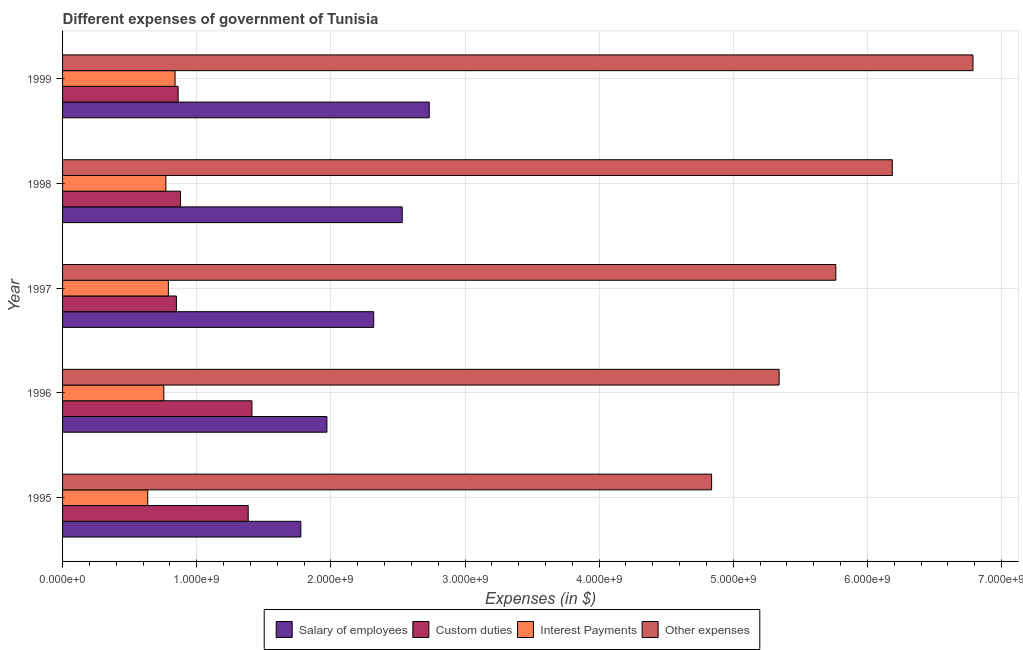How many different coloured bars are there?
Offer a terse response. 4. How many groups of bars are there?
Ensure brevity in your answer.  5. How many bars are there on the 4th tick from the top?
Your answer should be compact. 4. What is the label of the 2nd group of bars from the top?
Your answer should be very brief. 1998. In how many cases, is the number of bars for a given year not equal to the number of legend labels?
Offer a very short reply. 0. What is the amount spent on interest payments in 1996?
Give a very brief answer. 7.55e+08. Across all years, what is the maximum amount spent on other expenses?
Your answer should be compact. 6.79e+09. Across all years, what is the minimum amount spent on other expenses?
Provide a short and direct response. 4.84e+09. In which year was the amount spent on custom duties minimum?
Keep it short and to the point. 1997. What is the total amount spent on salary of employees in the graph?
Your response must be concise. 1.13e+1. What is the difference between the amount spent on salary of employees in 1998 and that in 1999?
Offer a very short reply. -2.01e+08. What is the difference between the amount spent on interest payments in 1997 and the amount spent on other expenses in 1996?
Offer a terse response. -4.55e+09. What is the average amount spent on interest payments per year?
Make the answer very short. 7.57e+08. In the year 1996, what is the difference between the amount spent on interest payments and amount spent on other expenses?
Your answer should be compact. -4.59e+09. What is the ratio of the amount spent on custom duties in 1998 to that in 1999?
Your answer should be compact. 1.02. Is the difference between the amount spent on custom duties in 1998 and 1999 greater than the difference between the amount spent on salary of employees in 1998 and 1999?
Your response must be concise. Yes. What is the difference between the highest and the second highest amount spent on other expenses?
Provide a succinct answer. 6.01e+08. What is the difference between the highest and the lowest amount spent on interest payments?
Give a very brief answer. 2.03e+08. In how many years, is the amount spent on other expenses greater than the average amount spent on other expenses taken over all years?
Make the answer very short. 2. Is the sum of the amount spent on other expenses in 1995 and 1997 greater than the maximum amount spent on salary of employees across all years?
Your answer should be very brief. Yes. Is it the case that in every year, the sum of the amount spent on other expenses and amount spent on custom duties is greater than the sum of amount spent on interest payments and amount spent on salary of employees?
Ensure brevity in your answer.  Yes. What does the 3rd bar from the top in 1999 represents?
Your answer should be very brief. Custom duties. What does the 2nd bar from the bottom in 1999 represents?
Your answer should be very brief. Custom duties. How many years are there in the graph?
Offer a very short reply. 5. What is the difference between two consecutive major ticks on the X-axis?
Your answer should be compact. 1.00e+09. Are the values on the major ticks of X-axis written in scientific E-notation?
Offer a terse response. Yes. Does the graph contain grids?
Ensure brevity in your answer.  Yes. How are the legend labels stacked?
Offer a very short reply. Horizontal. What is the title of the graph?
Keep it short and to the point. Different expenses of government of Tunisia. What is the label or title of the X-axis?
Your answer should be very brief. Expenses (in $). What is the Expenses (in $) of Salary of employees in 1995?
Your answer should be compact. 1.78e+09. What is the Expenses (in $) of Custom duties in 1995?
Keep it short and to the point. 1.38e+09. What is the Expenses (in $) in Interest Payments in 1995?
Your answer should be very brief. 6.35e+08. What is the Expenses (in $) in Other expenses in 1995?
Your answer should be very brief. 4.84e+09. What is the Expenses (in $) of Salary of employees in 1996?
Provide a succinct answer. 1.97e+09. What is the Expenses (in $) in Custom duties in 1996?
Make the answer very short. 1.41e+09. What is the Expenses (in $) of Interest Payments in 1996?
Offer a terse response. 7.55e+08. What is the Expenses (in $) in Other expenses in 1996?
Make the answer very short. 5.34e+09. What is the Expenses (in $) of Salary of employees in 1997?
Provide a succinct answer. 2.32e+09. What is the Expenses (in $) in Custom duties in 1997?
Ensure brevity in your answer.  8.49e+08. What is the Expenses (in $) of Interest Payments in 1997?
Keep it short and to the point. 7.89e+08. What is the Expenses (in $) in Other expenses in 1997?
Provide a short and direct response. 5.76e+09. What is the Expenses (in $) in Salary of employees in 1998?
Make the answer very short. 2.53e+09. What is the Expenses (in $) of Custom duties in 1998?
Your answer should be very brief. 8.79e+08. What is the Expenses (in $) in Interest Payments in 1998?
Offer a very short reply. 7.70e+08. What is the Expenses (in $) of Other expenses in 1998?
Give a very brief answer. 6.19e+09. What is the Expenses (in $) of Salary of employees in 1999?
Your answer should be very brief. 2.73e+09. What is the Expenses (in $) in Custom duties in 1999?
Your response must be concise. 8.62e+08. What is the Expenses (in $) in Interest Payments in 1999?
Give a very brief answer. 8.38e+08. What is the Expenses (in $) in Other expenses in 1999?
Your answer should be very brief. 6.79e+09. Across all years, what is the maximum Expenses (in $) of Salary of employees?
Your answer should be compact. 2.73e+09. Across all years, what is the maximum Expenses (in $) in Custom duties?
Offer a terse response. 1.41e+09. Across all years, what is the maximum Expenses (in $) of Interest Payments?
Provide a succinct answer. 8.38e+08. Across all years, what is the maximum Expenses (in $) in Other expenses?
Give a very brief answer. 6.79e+09. Across all years, what is the minimum Expenses (in $) of Salary of employees?
Ensure brevity in your answer.  1.78e+09. Across all years, what is the minimum Expenses (in $) of Custom duties?
Your answer should be compact. 8.49e+08. Across all years, what is the minimum Expenses (in $) of Interest Payments?
Your response must be concise. 6.35e+08. Across all years, what is the minimum Expenses (in $) of Other expenses?
Your answer should be compact. 4.84e+09. What is the total Expenses (in $) in Salary of employees in the graph?
Your answer should be very brief. 1.13e+1. What is the total Expenses (in $) in Custom duties in the graph?
Offer a very short reply. 5.39e+09. What is the total Expenses (in $) of Interest Payments in the graph?
Make the answer very short. 3.79e+09. What is the total Expenses (in $) of Other expenses in the graph?
Give a very brief answer. 2.89e+1. What is the difference between the Expenses (in $) in Salary of employees in 1995 and that in 1996?
Your answer should be very brief. -1.94e+08. What is the difference between the Expenses (in $) in Custom duties in 1995 and that in 1996?
Keep it short and to the point. -2.77e+07. What is the difference between the Expenses (in $) of Interest Payments in 1995 and that in 1996?
Offer a very short reply. -1.20e+08. What is the difference between the Expenses (in $) of Other expenses in 1995 and that in 1996?
Offer a very short reply. -5.03e+08. What is the difference between the Expenses (in $) of Salary of employees in 1995 and that in 1997?
Your answer should be very brief. -5.43e+08. What is the difference between the Expenses (in $) in Custom duties in 1995 and that in 1997?
Ensure brevity in your answer.  5.35e+08. What is the difference between the Expenses (in $) in Interest Payments in 1995 and that in 1997?
Your answer should be compact. -1.54e+08. What is the difference between the Expenses (in $) of Other expenses in 1995 and that in 1997?
Your answer should be compact. -9.26e+08. What is the difference between the Expenses (in $) of Salary of employees in 1995 and that in 1998?
Keep it short and to the point. -7.56e+08. What is the difference between the Expenses (in $) in Custom duties in 1995 and that in 1998?
Offer a very short reply. 5.05e+08. What is the difference between the Expenses (in $) of Interest Payments in 1995 and that in 1998?
Your response must be concise. -1.35e+08. What is the difference between the Expenses (in $) of Other expenses in 1995 and that in 1998?
Offer a very short reply. -1.35e+09. What is the difference between the Expenses (in $) in Salary of employees in 1995 and that in 1999?
Give a very brief answer. -9.57e+08. What is the difference between the Expenses (in $) of Custom duties in 1995 and that in 1999?
Offer a terse response. 5.22e+08. What is the difference between the Expenses (in $) of Interest Payments in 1995 and that in 1999?
Offer a terse response. -2.03e+08. What is the difference between the Expenses (in $) in Other expenses in 1995 and that in 1999?
Provide a short and direct response. -1.95e+09. What is the difference between the Expenses (in $) of Salary of employees in 1996 and that in 1997?
Offer a terse response. -3.49e+08. What is the difference between the Expenses (in $) of Custom duties in 1996 and that in 1997?
Ensure brevity in your answer.  5.63e+08. What is the difference between the Expenses (in $) of Interest Payments in 1996 and that in 1997?
Offer a very short reply. -3.40e+07. What is the difference between the Expenses (in $) of Other expenses in 1996 and that in 1997?
Your response must be concise. -4.22e+08. What is the difference between the Expenses (in $) in Salary of employees in 1996 and that in 1998?
Offer a very short reply. -5.62e+08. What is the difference between the Expenses (in $) of Custom duties in 1996 and that in 1998?
Provide a short and direct response. 5.32e+08. What is the difference between the Expenses (in $) in Interest Payments in 1996 and that in 1998?
Ensure brevity in your answer.  -1.53e+07. What is the difference between the Expenses (in $) of Other expenses in 1996 and that in 1998?
Your response must be concise. -8.44e+08. What is the difference between the Expenses (in $) of Salary of employees in 1996 and that in 1999?
Offer a very short reply. -7.63e+08. What is the difference between the Expenses (in $) of Custom duties in 1996 and that in 1999?
Your response must be concise. 5.50e+08. What is the difference between the Expenses (in $) of Interest Payments in 1996 and that in 1999?
Your answer should be compact. -8.38e+07. What is the difference between the Expenses (in $) of Other expenses in 1996 and that in 1999?
Give a very brief answer. -1.44e+09. What is the difference between the Expenses (in $) in Salary of employees in 1997 and that in 1998?
Provide a succinct answer. -2.13e+08. What is the difference between the Expenses (in $) of Custom duties in 1997 and that in 1998?
Your answer should be very brief. -3.08e+07. What is the difference between the Expenses (in $) in Interest Payments in 1997 and that in 1998?
Provide a succinct answer. 1.87e+07. What is the difference between the Expenses (in $) in Other expenses in 1997 and that in 1998?
Provide a short and direct response. -4.21e+08. What is the difference between the Expenses (in $) of Salary of employees in 1997 and that in 1999?
Make the answer very short. -4.14e+08. What is the difference between the Expenses (in $) of Custom duties in 1997 and that in 1999?
Your answer should be compact. -1.29e+07. What is the difference between the Expenses (in $) in Interest Payments in 1997 and that in 1999?
Provide a succinct answer. -4.98e+07. What is the difference between the Expenses (in $) in Other expenses in 1997 and that in 1999?
Provide a short and direct response. -1.02e+09. What is the difference between the Expenses (in $) of Salary of employees in 1998 and that in 1999?
Make the answer very short. -2.01e+08. What is the difference between the Expenses (in $) of Custom duties in 1998 and that in 1999?
Give a very brief answer. 1.79e+07. What is the difference between the Expenses (in $) of Interest Payments in 1998 and that in 1999?
Your response must be concise. -6.85e+07. What is the difference between the Expenses (in $) of Other expenses in 1998 and that in 1999?
Give a very brief answer. -6.01e+08. What is the difference between the Expenses (in $) in Salary of employees in 1995 and the Expenses (in $) in Custom duties in 1996?
Your answer should be compact. 3.64e+08. What is the difference between the Expenses (in $) of Salary of employees in 1995 and the Expenses (in $) of Interest Payments in 1996?
Offer a terse response. 1.02e+09. What is the difference between the Expenses (in $) of Salary of employees in 1995 and the Expenses (in $) of Other expenses in 1996?
Offer a terse response. -3.57e+09. What is the difference between the Expenses (in $) in Custom duties in 1995 and the Expenses (in $) in Interest Payments in 1996?
Offer a very short reply. 6.29e+08. What is the difference between the Expenses (in $) in Custom duties in 1995 and the Expenses (in $) in Other expenses in 1996?
Offer a terse response. -3.96e+09. What is the difference between the Expenses (in $) of Interest Payments in 1995 and the Expenses (in $) of Other expenses in 1996?
Offer a very short reply. -4.71e+09. What is the difference between the Expenses (in $) in Salary of employees in 1995 and the Expenses (in $) in Custom duties in 1997?
Give a very brief answer. 9.28e+08. What is the difference between the Expenses (in $) in Salary of employees in 1995 and the Expenses (in $) in Interest Payments in 1997?
Offer a terse response. 9.88e+08. What is the difference between the Expenses (in $) of Salary of employees in 1995 and the Expenses (in $) of Other expenses in 1997?
Make the answer very short. -3.99e+09. What is the difference between the Expenses (in $) in Custom duties in 1995 and the Expenses (in $) in Interest Payments in 1997?
Provide a short and direct response. 5.95e+08. What is the difference between the Expenses (in $) of Custom duties in 1995 and the Expenses (in $) of Other expenses in 1997?
Provide a succinct answer. -4.38e+09. What is the difference between the Expenses (in $) of Interest Payments in 1995 and the Expenses (in $) of Other expenses in 1997?
Offer a very short reply. -5.13e+09. What is the difference between the Expenses (in $) in Salary of employees in 1995 and the Expenses (in $) in Custom duties in 1998?
Offer a terse response. 8.97e+08. What is the difference between the Expenses (in $) in Salary of employees in 1995 and the Expenses (in $) in Interest Payments in 1998?
Your answer should be compact. 1.01e+09. What is the difference between the Expenses (in $) in Salary of employees in 1995 and the Expenses (in $) in Other expenses in 1998?
Provide a succinct answer. -4.41e+09. What is the difference between the Expenses (in $) in Custom duties in 1995 and the Expenses (in $) in Interest Payments in 1998?
Provide a succinct answer. 6.14e+08. What is the difference between the Expenses (in $) in Custom duties in 1995 and the Expenses (in $) in Other expenses in 1998?
Your response must be concise. -4.80e+09. What is the difference between the Expenses (in $) in Interest Payments in 1995 and the Expenses (in $) in Other expenses in 1998?
Keep it short and to the point. -5.55e+09. What is the difference between the Expenses (in $) in Salary of employees in 1995 and the Expenses (in $) in Custom duties in 1999?
Offer a very short reply. 9.15e+08. What is the difference between the Expenses (in $) in Salary of employees in 1995 and the Expenses (in $) in Interest Payments in 1999?
Your answer should be compact. 9.38e+08. What is the difference between the Expenses (in $) of Salary of employees in 1995 and the Expenses (in $) of Other expenses in 1999?
Offer a very short reply. -5.01e+09. What is the difference between the Expenses (in $) of Custom duties in 1995 and the Expenses (in $) of Interest Payments in 1999?
Give a very brief answer. 5.46e+08. What is the difference between the Expenses (in $) of Custom duties in 1995 and the Expenses (in $) of Other expenses in 1999?
Your answer should be very brief. -5.40e+09. What is the difference between the Expenses (in $) in Interest Payments in 1995 and the Expenses (in $) in Other expenses in 1999?
Your response must be concise. -6.15e+09. What is the difference between the Expenses (in $) in Salary of employees in 1996 and the Expenses (in $) in Custom duties in 1997?
Keep it short and to the point. 1.12e+09. What is the difference between the Expenses (in $) of Salary of employees in 1996 and the Expenses (in $) of Interest Payments in 1997?
Offer a very short reply. 1.18e+09. What is the difference between the Expenses (in $) in Salary of employees in 1996 and the Expenses (in $) in Other expenses in 1997?
Keep it short and to the point. -3.79e+09. What is the difference between the Expenses (in $) of Custom duties in 1996 and the Expenses (in $) of Interest Payments in 1997?
Ensure brevity in your answer.  6.23e+08. What is the difference between the Expenses (in $) of Custom duties in 1996 and the Expenses (in $) of Other expenses in 1997?
Give a very brief answer. -4.35e+09. What is the difference between the Expenses (in $) of Interest Payments in 1996 and the Expenses (in $) of Other expenses in 1997?
Ensure brevity in your answer.  -5.01e+09. What is the difference between the Expenses (in $) in Salary of employees in 1996 and the Expenses (in $) in Custom duties in 1998?
Your answer should be compact. 1.09e+09. What is the difference between the Expenses (in $) of Salary of employees in 1996 and the Expenses (in $) of Interest Payments in 1998?
Your response must be concise. 1.20e+09. What is the difference between the Expenses (in $) of Salary of employees in 1996 and the Expenses (in $) of Other expenses in 1998?
Provide a short and direct response. -4.21e+09. What is the difference between the Expenses (in $) of Custom duties in 1996 and the Expenses (in $) of Interest Payments in 1998?
Offer a very short reply. 6.42e+08. What is the difference between the Expenses (in $) in Custom duties in 1996 and the Expenses (in $) in Other expenses in 1998?
Ensure brevity in your answer.  -4.77e+09. What is the difference between the Expenses (in $) of Interest Payments in 1996 and the Expenses (in $) of Other expenses in 1998?
Your answer should be very brief. -5.43e+09. What is the difference between the Expenses (in $) in Salary of employees in 1996 and the Expenses (in $) in Custom duties in 1999?
Make the answer very short. 1.11e+09. What is the difference between the Expenses (in $) in Salary of employees in 1996 and the Expenses (in $) in Interest Payments in 1999?
Your response must be concise. 1.13e+09. What is the difference between the Expenses (in $) in Salary of employees in 1996 and the Expenses (in $) in Other expenses in 1999?
Your answer should be compact. -4.82e+09. What is the difference between the Expenses (in $) of Custom duties in 1996 and the Expenses (in $) of Interest Payments in 1999?
Your response must be concise. 5.73e+08. What is the difference between the Expenses (in $) of Custom duties in 1996 and the Expenses (in $) of Other expenses in 1999?
Ensure brevity in your answer.  -5.38e+09. What is the difference between the Expenses (in $) of Interest Payments in 1996 and the Expenses (in $) of Other expenses in 1999?
Your response must be concise. -6.03e+09. What is the difference between the Expenses (in $) of Salary of employees in 1997 and the Expenses (in $) of Custom duties in 1998?
Offer a very short reply. 1.44e+09. What is the difference between the Expenses (in $) in Salary of employees in 1997 and the Expenses (in $) in Interest Payments in 1998?
Keep it short and to the point. 1.55e+09. What is the difference between the Expenses (in $) of Salary of employees in 1997 and the Expenses (in $) of Other expenses in 1998?
Your answer should be compact. -3.87e+09. What is the difference between the Expenses (in $) in Custom duties in 1997 and the Expenses (in $) in Interest Payments in 1998?
Provide a short and direct response. 7.86e+07. What is the difference between the Expenses (in $) in Custom duties in 1997 and the Expenses (in $) in Other expenses in 1998?
Offer a terse response. -5.34e+09. What is the difference between the Expenses (in $) of Interest Payments in 1997 and the Expenses (in $) of Other expenses in 1998?
Your answer should be compact. -5.40e+09. What is the difference between the Expenses (in $) in Salary of employees in 1997 and the Expenses (in $) in Custom duties in 1999?
Keep it short and to the point. 1.46e+09. What is the difference between the Expenses (in $) of Salary of employees in 1997 and the Expenses (in $) of Interest Payments in 1999?
Ensure brevity in your answer.  1.48e+09. What is the difference between the Expenses (in $) in Salary of employees in 1997 and the Expenses (in $) in Other expenses in 1999?
Your response must be concise. -4.47e+09. What is the difference between the Expenses (in $) in Custom duties in 1997 and the Expenses (in $) in Interest Payments in 1999?
Offer a very short reply. 1.01e+07. What is the difference between the Expenses (in $) in Custom duties in 1997 and the Expenses (in $) in Other expenses in 1999?
Offer a very short reply. -5.94e+09. What is the difference between the Expenses (in $) in Interest Payments in 1997 and the Expenses (in $) in Other expenses in 1999?
Keep it short and to the point. -6.00e+09. What is the difference between the Expenses (in $) of Salary of employees in 1998 and the Expenses (in $) of Custom duties in 1999?
Offer a very short reply. 1.67e+09. What is the difference between the Expenses (in $) in Salary of employees in 1998 and the Expenses (in $) in Interest Payments in 1999?
Your response must be concise. 1.69e+09. What is the difference between the Expenses (in $) in Salary of employees in 1998 and the Expenses (in $) in Other expenses in 1999?
Offer a terse response. -4.25e+09. What is the difference between the Expenses (in $) in Custom duties in 1998 and the Expenses (in $) in Interest Payments in 1999?
Offer a terse response. 4.09e+07. What is the difference between the Expenses (in $) of Custom duties in 1998 and the Expenses (in $) of Other expenses in 1999?
Your answer should be compact. -5.91e+09. What is the difference between the Expenses (in $) in Interest Payments in 1998 and the Expenses (in $) in Other expenses in 1999?
Provide a short and direct response. -6.02e+09. What is the average Expenses (in $) of Salary of employees per year?
Offer a terse response. 2.27e+09. What is the average Expenses (in $) of Custom duties per year?
Provide a succinct answer. 1.08e+09. What is the average Expenses (in $) of Interest Payments per year?
Offer a terse response. 7.57e+08. What is the average Expenses (in $) in Other expenses per year?
Your answer should be compact. 5.78e+09. In the year 1995, what is the difference between the Expenses (in $) of Salary of employees and Expenses (in $) of Custom duties?
Make the answer very short. 3.92e+08. In the year 1995, what is the difference between the Expenses (in $) of Salary of employees and Expenses (in $) of Interest Payments?
Offer a terse response. 1.14e+09. In the year 1995, what is the difference between the Expenses (in $) of Salary of employees and Expenses (in $) of Other expenses?
Ensure brevity in your answer.  -3.06e+09. In the year 1995, what is the difference between the Expenses (in $) of Custom duties and Expenses (in $) of Interest Payments?
Your response must be concise. 7.49e+08. In the year 1995, what is the difference between the Expenses (in $) of Custom duties and Expenses (in $) of Other expenses?
Your response must be concise. -3.45e+09. In the year 1995, what is the difference between the Expenses (in $) of Interest Payments and Expenses (in $) of Other expenses?
Your answer should be compact. -4.20e+09. In the year 1996, what is the difference between the Expenses (in $) in Salary of employees and Expenses (in $) in Custom duties?
Offer a terse response. 5.59e+08. In the year 1996, what is the difference between the Expenses (in $) of Salary of employees and Expenses (in $) of Interest Payments?
Offer a terse response. 1.22e+09. In the year 1996, what is the difference between the Expenses (in $) of Salary of employees and Expenses (in $) of Other expenses?
Provide a succinct answer. -3.37e+09. In the year 1996, what is the difference between the Expenses (in $) of Custom duties and Expenses (in $) of Interest Payments?
Keep it short and to the point. 6.57e+08. In the year 1996, what is the difference between the Expenses (in $) of Custom duties and Expenses (in $) of Other expenses?
Ensure brevity in your answer.  -3.93e+09. In the year 1996, what is the difference between the Expenses (in $) of Interest Payments and Expenses (in $) of Other expenses?
Give a very brief answer. -4.59e+09. In the year 1997, what is the difference between the Expenses (in $) in Salary of employees and Expenses (in $) in Custom duties?
Your answer should be very brief. 1.47e+09. In the year 1997, what is the difference between the Expenses (in $) in Salary of employees and Expenses (in $) in Interest Payments?
Provide a short and direct response. 1.53e+09. In the year 1997, what is the difference between the Expenses (in $) of Salary of employees and Expenses (in $) of Other expenses?
Give a very brief answer. -3.44e+09. In the year 1997, what is the difference between the Expenses (in $) of Custom duties and Expenses (in $) of Interest Payments?
Make the answer very short. 5.99e+07. In the year 1997, what is the difference between the Expenses (in $) in Custom duties and Expenses (in $) in Other expenses?
Offer a very short reply. -4.92e+09. In the year 1997, what is the difference between the Expenses (in $) in Interest Payments and Expenses (in $) in Other expenses?
Give a very brief answer. -4.98e+09. In the year 1998, what is the difference between the Expenses (in $) in Salary of employees and Expenses (in $) in Custom duties?
Give a very brief answer. 1.65e+09. In the year 1998, what is the difference between the Expenses (in $) of Salary of employees and Expenses (in $) of Interest Payments?
Provide a succinct answer. 1.76e+09. In the year 1998, what is the difference between the Expenses (in $) in Salary of employees and Expenses (in $) in Other expenses?
Keep it short and to the point. -3.65e+09. In the year 1998, what is the difference between the Expenses (in $) of Custom duties and Expenses (in $) of Interest Payments?
Give a very brief answer. 1.09e+08. In the year 1998, what is the difference between the Expenses (in $) in Custom duties and Expenses (in $) in Other expenses?
Your answer should be compact. -5.31e+09. In the year 1998, what is the difference between the Expenses (in $) of Interest Payments and Expenses (in $) of Other expenses?
Ensure brevity in your answer.  -5.42e+09. In the year 1999, what is the difference between the Expenses (in $) in Salary of employees and Expenses (in $) in Custom duties?
Offer a terse response. 1.87e+09. In the year 1999, what is the difference between the Expenses (in $) in Salary of employees and Expenses (in $) in Interest Payments?
Keep it short and to the point. 1.90e+09. In the year 1999, what is the difference between the Expenses (in $) in Salary of employees and Expenses (in $) in Other expenses?
Provide a short and direct response. -4.05e+09. In the year 1999, what is the difference between the Expenses (in $) of Custom duties and Expenses (in $) of Interest Payments?
Provide a short and direct response. 2.30e+07. In the year 1999, what is the difference between the Expenses (in $) in Custom duties and Expenses (in $) in Other expenses?
Give a very brief answer. -5.93e+09. In the year 1999, what is the difference between the Expenses (in $) in Interest Payments and Expenses (in $) in Other expenses?
Your response must be concise. -5.95e+09. What is the ratio of the Expenses (in $) of Salary of employees in 1995 to that in 1996?
Your answer should be compact. 0.9. What is the ratio of the Expenses (in $) in Custom duties in 1995 to that in 1996?
Give a very brief answer. 0.98. What is the ratio of the Expenses (in $) in Interest Payments in 1995 to that in 1996?
Offer a very short reply. 0.84. What is the ratio of the Expenses (in $) of Other expenses in 1995 to that in 1996?
Keep it short and to the point. 0.91. What is the ratio of the Expenses (in $) of Salary of employees in 1995 to that in 1997?
Ensure brevity in your answer.  0.77. What is the ratio of the Expenses (in $) in Custom duties in 1995 to that in 1997?
Offer a terse response. 1.63. What is the ratio of the Expenses (in $) of Interest Payments in 1995 to that in 1997?
Your answer should be compact. 0.81. What is the ratio of the Expenses (in $) in Other expenses in 1995 to that in 1997?
Your response must be concise. 0.84. What is the ratio of the Expenses (in $) in Salary of employees in 1995 to that in 1998?
Your answer should be compact. 0.7. What is the ratio of the Expenses (in $) of Custom duties in 1995 to that in 1998?
Make the answer very short. 1.57. What is the ratio of the Expenses (in $) in Interest Payments in 1995 to that in 1998?
Your response must be concise. 0.82. What is the ratio of the Expenses (in $) of Other expenses in 1995 to that in 1998?
Offer a terse response. 0.78. What is the ratio of the Expenses (in $) in Salary of employees in 1995 to that in 1999?
Ensure brevity in your answer.  0.65. What is the ratio of the Expenses (in $) of Custom duties in 1995 to that in 1999?
Make the answer very short. 1.61. What is the ratio of the Expenses (in $) in Interest Payments in 1995 to that in 1999?
Provide a short and direct response. 0.76. What is the ratio of the Expenses (in $) of Other expenses in 1995 to that in 1999?
Offer a very short reply. 0.71. What is the ratio of the Expenses (in $) of Salary of employees in 1996 to that in 1997?
Your answer should be compact. 0.85. What is the ratio of the Expenses (in $) in Custom duties in 1996 to that in 1997?
Offer a terse response. 1.66. What is the ratio of the Expenses (in $) of Interest Payments in 1996 to that in 1997?
Give a very brief answer. 0.96. What is the ratio of the Expenses (in $) of Other expenses in 1996 to that in 1997?
Your answer should be very brief. 0.93. What is the ratio of the Expenses (in $) in Salary of employees in 1996 to that in 1998?
Offer a terse response. 0.78. What is the ratio of the Expenses (in $) in Custom duties in 1996 to that in 1998?
Your answer should be compact. 1.61. What is the ratio of the Expenses (in $) in Interest Payments in 1996 to that in 1998?
Provide a short and direct response. 0.98. What is the ratio of the Expenses (in $) of Other expenses in 1996 to that in 1998?
Your response must be concise. 0.86. What is the ratio of the Expenses (in $) in Salary of employees in 1996 to that in 1999?
Keep it short and to the point. 0.72. What is the ratio of the Expenses (in $) in Custom duties in 1996 to that in 1999?
Keep it short and to the point. 1.64. What is the ratio of the Expenses (in $) in Interest Payments in 1996 to that in 1999?
Ensure brevity in your answer.  0.9. What is the ratio of the Expenses (in $) of Other expenses in 1996 to that in 1999?
Keep it short and to the point. 0.79. What is the ratio of the Expenses (in $) of Salary of employees in 1997 to that in 1998?
Give a very brief answer. 0.92. What is the ratio of the Expenses (in $) of Custom duties in 1997 to that in 1998?
Give a very brief answer. 0.96. What is the ratio of the Expenses (in $) in Interest Payments in 1997 to that in 1998?
Offer a very short reply. 1.02. What is the ratio of the Expenses (in $) of Other expenses in 1997 to that in 1998?
Offer a terse response. 0.93. What is the ratio of the Expenses (in $) in Salary of employees in 1997 to that in 1999?
Your answer should be very brief. 0.85. What is the ratio of the Expenses (in $) in Interest Payments in 1997 to that in 1999?
Offer a very short reply. 0.94. What is the ratio of the Expenses (in $) in Other expenses in 1997 to that in 1999?
Your response must be concise. 0.85. What is the ratio of the Expenses (in $) in Salary of employees in 1998 to that in 1999?
Your answer should be very brief. 0.93. What is the ratio of the Expenses (in $) of Custom duties in 1998 to that in 1999?
Offer a terse response. 1.02. What is the ratio of the Expenses (in $) of Interest Payments in 1998 to that in 1999?
Give a very brief answer. 0.92. What is the ratio of the Expenses (in $) of Other expenses in 1998 to that in 1999?
Offer a very short reply. 0.91. What is the difference between the highest and the second highest Expenses (in $) of Salary of employees?
Your answer should be compact. 2.01e+08. What is the difference between the highest and the second highest Expenses (in $) in Custom duties?
Your answer should be compact. 2.77e+07. What is the difference between the highest and the second highest Expenses (in $) of Interest Payments?
Provide a succinct answer. 4.98e+07. What is the difference between the highest and the second highest Expenses (in $) of Other expenses?
Provide a short and direct response. 6.01e+08. What is the difference between the highest and the lowest Expenses (in $) of Salary of employees?
Make the answer very short. 9.57e+08. What is the difference between the highest and the lowest Expenses (in $) in Custom duties?
Ensure brevity in your answer.  5.63e+08. What is the difference between the highest and the lowest Expenses (in $) in Interest Payments?
Your answer should be compact. 2.03e+08. What is the difference between the highest and the lowest Expenses (in $) in Other expenses?
Keep it short and to the point. 1.95e+09. 